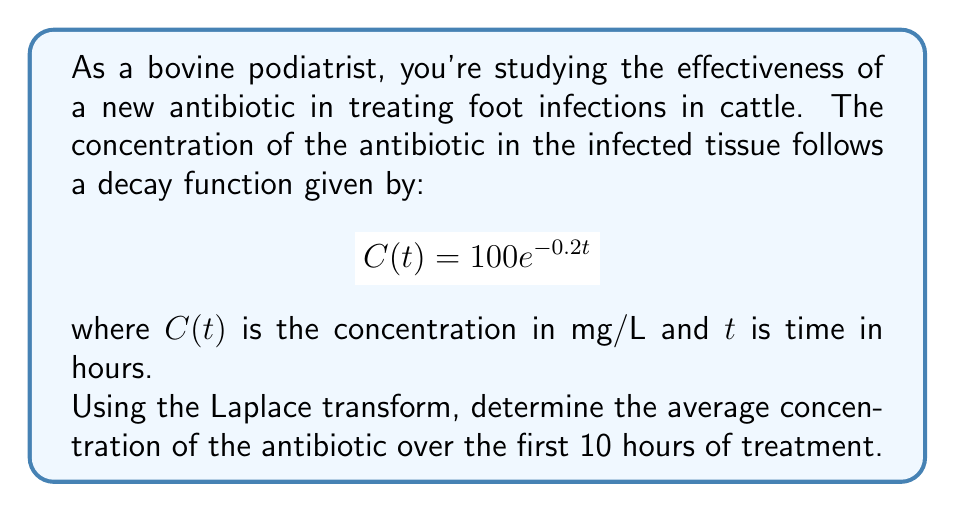Show me your answer to this math problem. Let's approach this step-by-step:

1) The average concentration over time T is given by:

   $$C_{avg} = \frac{1}{T}\int_0^T C(t) dt$$

2) In our case, T = 10 hours and C(t) = 100e^(-0.2t). So we need to calculate:

   $$C_{avg} = \frac{1}{10}\int_0^{10} 100e^{-0.2t} dt$$

3) To solve this using Laplace transforms, let's first recall that:

   $$\mathcal{L}\{f(t)\} = F(s) = \int_0^{\infty} e^{-st}f(t) dt$$

4) We can use the property:

   $$\int_0^T f(t) dt = \frac{1}{s}F(s) - \frac{1}{s}\mathcal{L}\{f(T-t)\}$$

5) In our case, $f(t) = 100e^{-0.2t}$. We know that:

   $$\mathcal{L}\{e^{-at}\} = \frac{1}{s+a}$$

   So, $F(s) = \frac{100}{s+0.2}$

6) Now, $f(10-t) = 100e^{-0.2(10-t)} = 100e^{-2}e^{0.2t}$

   $$\mathcal{L}\{f(10-t)\} = 100e^{-2}\cdot\frac{1}{s-0.2}$$

7) Substituting into the formula from step 4:

   $$\int_0^{10} 100e^{-0.2t} dt = \frac{1}{s}\cdot\frac{100}{s+0.2} - \frac{1}{s}\cdot100e^{-2}\cdot\frac{1}{s-0.2}$$

8) Evaluating at s = 0:

   $$\int_0^{10} 100e^{-0.2t} dt = \frac{100}{0.2} - 100e^{-2}\cdot\frac{1}{-0.2} = 500 - 500e^{-2}$$

9) Therefore, the average concentration is:

   $$C_{avg} = \frac{1}{10}(500 - 500e^{-2}) = 50 - 50e^{-2}$$

10) Calculating this value:

    $$C_{avg} \approx 50 - 50(0.1353) \approx 43.235 \text{ mg/L}$$
Answer: 43.235 mg/L 